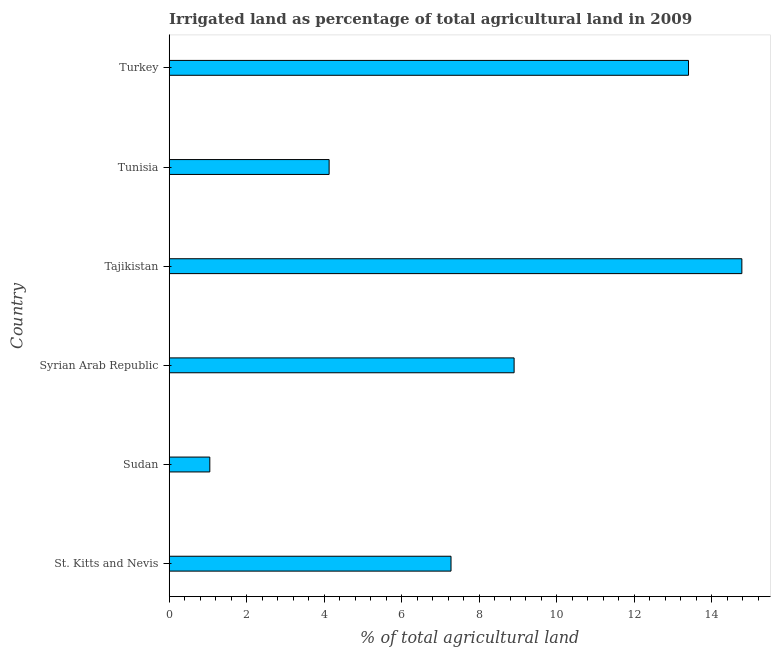What is the title of the graph?
Keep it short and to the point. Irrigated land as percentage of total agricultural land in 2009. What is the label or title of the X-axis?
Offer a terse response. % of total agricultural land. What is the percentage of agricultural irrigated land in Turkey?
Give a very brief answer. 13.4. Across all countries, what is the maximum percentage of agricultural irrigated land?
Your answer should be compact. 14.78. Across all countries, what is the minimum percentage of agricultural irrigated land?
Your response must be concise. 1.05. In which country was the percentage of agricultural irrigated land maximum?
Offer a very short reply. Tajikistan. In which country was the percentage of agricultural irrigated land minimum?
Ensure brevity in your answer.  Sudan. What is the sum of the percentage of agricultural irrigated land?
Give a very brief answer. 49.53. What is the difference between the percentage of agricultural irrigated land in Syrian Arab Republic and Tunisia?
Offer a very short reply. 4.77. What is the average percentage of agricultural irrigated land per country?
Provide a short and direct response. 8.26. What is the median percentage of agricultural irrigated land?
Give a very brief answer. 8.09. What is the ratio of the percentage of agricultural irrigated land in St. Kitts and Nevis to that in Turkey?
Provide a short and direct response. 0.54. What is the difference between the highest and the second highest percentage of agricultural irrigated land?
Offer a very short reply. 1.38. What is the difference between the highest and the lowest percentage of agricultural irrigated land?
Make the answer very short. 13.73. In how many countries, is the percentage of agricultural irrigated land greater than the average percentage of agricultural irrigated land taken over all countries?
Keep it short and to the point. 3. How many bars are there?
Your answer should be very brief. 6. What is the % of total agricultural land of St. Kitts and Nevis?
Your response must be concise. 7.27. What is the % of total agricultural land of Sudan?
Your response must be concise. 1.05. What is the % of total agricultural land of Syrian Arab Republic?
Keep it short and to the point. 8.9. What is the % of total agricultural land of Tajikistan?
Your response must be concise. 14.78. What is the % of total agricultural land in Tunisia?
Give a very brief answer. 4.13. What is the % of total agricultural land in Turkey?
Your answer should be compact. 13.4. What is the difference between the % of total agricultural land in St. Kitts and Nevis and Sudan?
Ensure brevity in your answer.  6.22. What is the difference between the % of total agricultural land in St. Kitts and Nevis and Syrian Arab Republic?
Ensure brevity in your answer.  -1.63. What is the difference between the % of total agricultural land in St. Kitts and Nevis and Tajikistan?
Provide a succinct answer. -7.51. What is the difference between the % of total agricultural land in St. Kitts and Nevis and Tunisia?
Provide a succinct answer. 3.15. What is the difference between the % of total agricultural land in St. Kitts and Nevis and Turkey?
Your response must be concise. -6.13. What is the difference between the % of total agricultural land in Sudan and Syrian Arab Republic?
Provide a succinct answer. -7.85. What is the difference between the % of total agricultural land in Sudan and Tajikistan?
Offer a terse response. -13.73. What is the difference between the % of total agricultural land in Sudan and Tunisia?
Offer a terse response. -3.08. What is the difference between the % of total agricultural land in Sudan and Turkey?
Your answer should be very brief. -12.35. What is the difference between the % of total agricultural land in Syrian Arab Republic and Tajikistan?
Offer a terse response. -5.88. What is the difference between the % of total agricultural land in Syrian Arab Republic and Tunisia?
Ensure brevity in your answer.  4.77. What is the difference between the % of total agricultural land in Syrian Arab Republic and Turkey?
Make the answer very short. -4.5. What is the difference between the % of total agricultural land in Tajikistan and Tunisia?
Ensure brevity in your answer.  10.65. What is the difference between the % of total agricultural land in Tajikistan and Turkey?
Make the answer very short. 1.38. What is the difference between the % of total agricultural land in Tunisia and Turkey?
Your response must be concise. -9.28. What is the ratio of the % of total agricultural land in St. Kitts and Nevis to that in Sudan?
Your answer should be very brief. 6.94. What is the ratio of the % of total agricultural land in St. Kitts and Nevis to that in Syrian Arab Republic?
Your answer should be very brief. 0.82. What is the ratio of the % of total agricultural land in St. Kitts and Nevis to that in Tajikistan?
Make the answer very short. 0.49. What is the ratio of the % of total agricultural land in St. Kitts and Nevis to that in Tunisia?
Keep it short and to the point. 1.76. What is the ratio of the % of total agricultural land in St. Kitts and Nevis to that in Turkey?
Offer a very short reply. 0.54. What is the ratio of the % of total agricultural land in Sudan to that in Syrian Arab Republic?
Your response must be concise. 0.12. What is the ratio of the % of total agricultural land in Sudan to that in Tajikistan?
Give a very brief answer. 0.07. What is the ratio of the % of total agricultural land in Sudan to that in Tunisia?
Give a very brief answer. 0.25. What is the ratio of the % of total agricultural land in Sudan to that in Turkey?
Provide a short and direct response. 0.08. What is the ratio of the % of total agricultural land in Syrian Arab Republic to that in Tajikistan?
Make the answer very short. 0.6. What is the ratio of the % of total agricultural land in Syrian Arab Republic to that in Tunisia?
Offer a terse response. 2.16. What is the ratio of the % of total agricultural land in Syrian Arab Republic to that in Turkey?
Ensure brevity in your answer.  0.66. What is the ratio of the % of total agricultural land in Tajikistan to that in Tunisia?
Offer a very short reply. 3.58. What is the ratio of the % of total agricultural land in Tajikistan to that in Turkey?
Keep it short and to the point. 1.1. What is the ratio of the % of total agricultural land in Tunisia to that in Turkey?
Your answer should be compact. 0.31. 